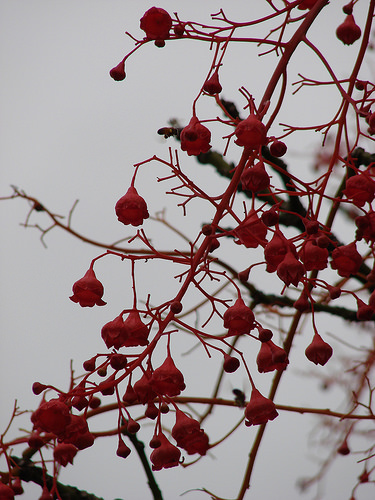<image>
Is there a fruits behind the brown branch? No. The fruits is not behind the brown branch. From this viewpoint, the fruits appears to be positioned elsewhere in the scene. Is the flower next to the sky? No. The flower is not positioned next to the sky. They are located in different areas of the scene. 